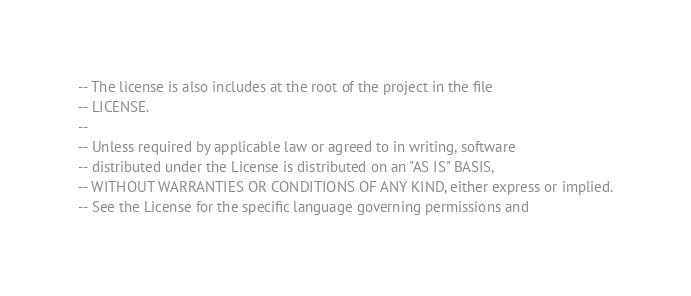<code> <loc_0><loc_0><loc_500><loc_500><_SQL_>-- The license is also includes at the root of the project in the file
-- LICENSE.
--
-- Unless required by applicable law or agreed to in writing, software
-- distributed under the License is distributed on an "AS IS" BASIS,
-- WITHOUT WARRANTIES OR CONDITIONS OF ANY KIND, either express or implied.
-- See the License for the specific language governing permissions and</code> 